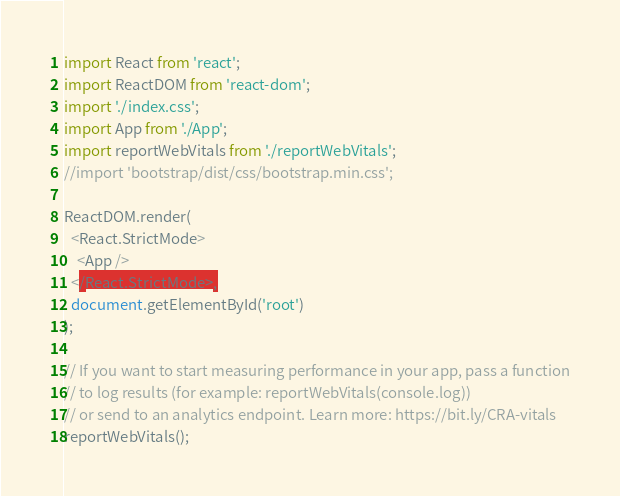<code> <loc_0><loc_0><loc_500><loc_500><_JavaScript_>import React from 'react';
import ReactDOM from 'react-dom';
import './index.css';
import App from './App';
import reportWebVitals from './reportWebVitals';
//import 'bootstrap/dist/css/bootstrap.min.css';

ReactDOM.render(
  <React.StrictMode>
    <App />
  </React.StrictMode>,
  document.getElementById('root')
);

// If you want to start measuring performance in your app, pass a function
// to log results (for example: reportWebVitals(console.log))
// or send to an analytics endpoint. Learn more: https://bit.ly/CRA-vitals
reportWebVitals();
</code> 